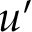Convert formula to latex. <formula><loc_0><loc_0><loc_500><loc_500>u ^ { \prime }</formula> 